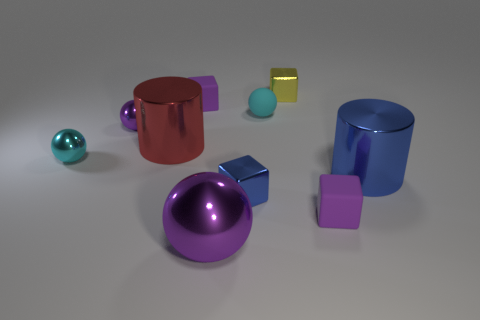What is the material of the large red cylinder?
Your answer should be compact. Metal. What number of other shiny things have the same shape as the yellow metallic object?
Offer a very short reply. 1. There is another small ball that is the same color as the rubber sphere; what is it made of?
Provide a short and direct response. Metal. Are there any other things that are the same shape as the big red object?
Your answer should be compact. Yes. What color is the small shiny block that is behind the big metallic object that is behind the cyan ball left of the red metal object?
Your answer should be very brief. Yellow. How many small objects are either cubes or yellow rubber spheres?
Your answer should be compact. 4. Are there the same number of matte cubes right of the yellow cube and cyan matte balls?
Make the answer very short. Yes. There is a big purple metallic ball; are there any purple things on the left side of it?
Ensure brevity in your answer.  Yes. How many matte objects are tiny cyan spheres or large red things?
Your answer should be very brief. 1. How many tiny blue metal things are behind the tiny yellow metallic block?
Your answer should be compact. 0. 